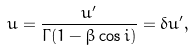<formula> <loc_0><loc_0><loc_500><loc_500>u = \frac { u ^ { \prime } } { \Gamma ( 1 - \beta \cos i ) } = \delta u ^ { \prime } ,</formula> 